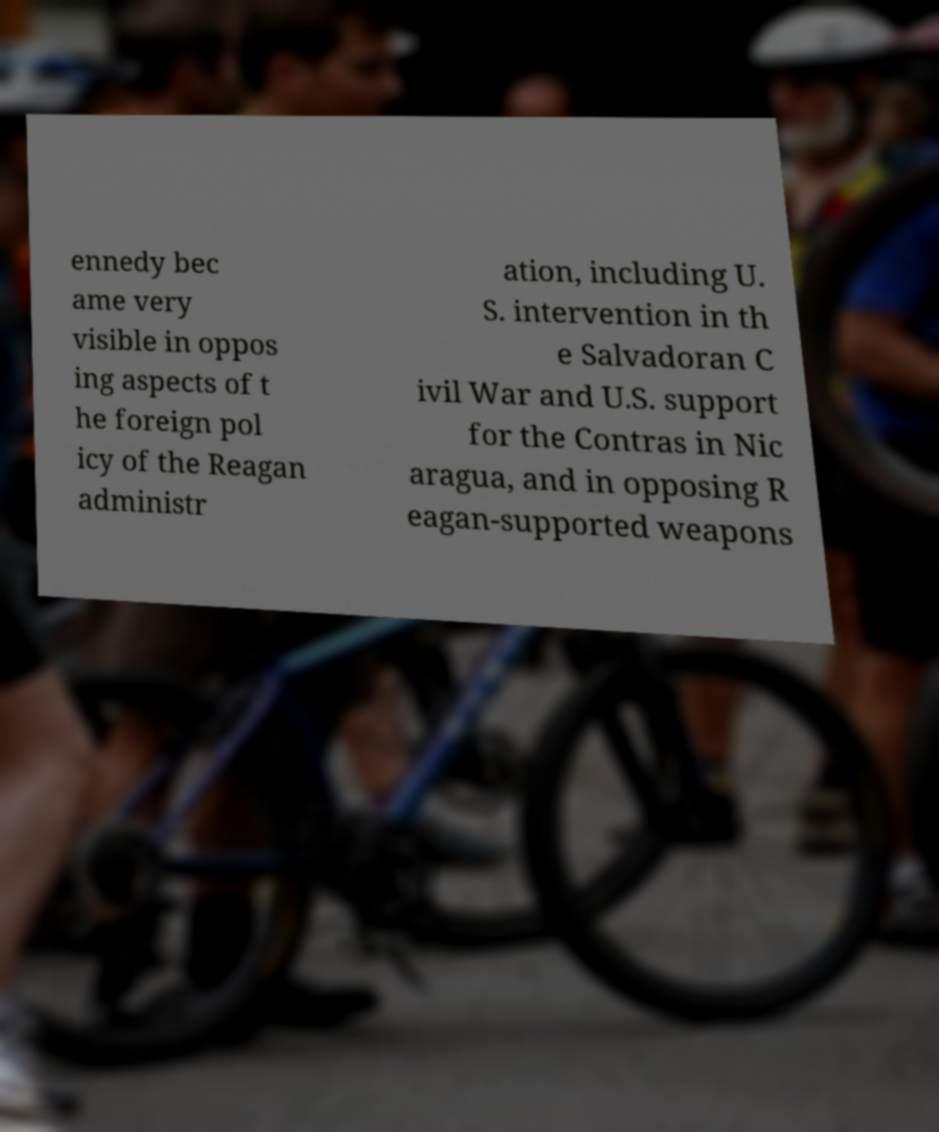I need the written content from this picture converted into text. Can you do that? ennedy bec ame very visible in oppos ing aspects of t he foreign pol icy of the Reagan administr ation, including U. S. intervention in th e Salvadoran C ivil War and U.S. support for the Contras in Nic aragua, and in opposing R eagan-supported weapons 